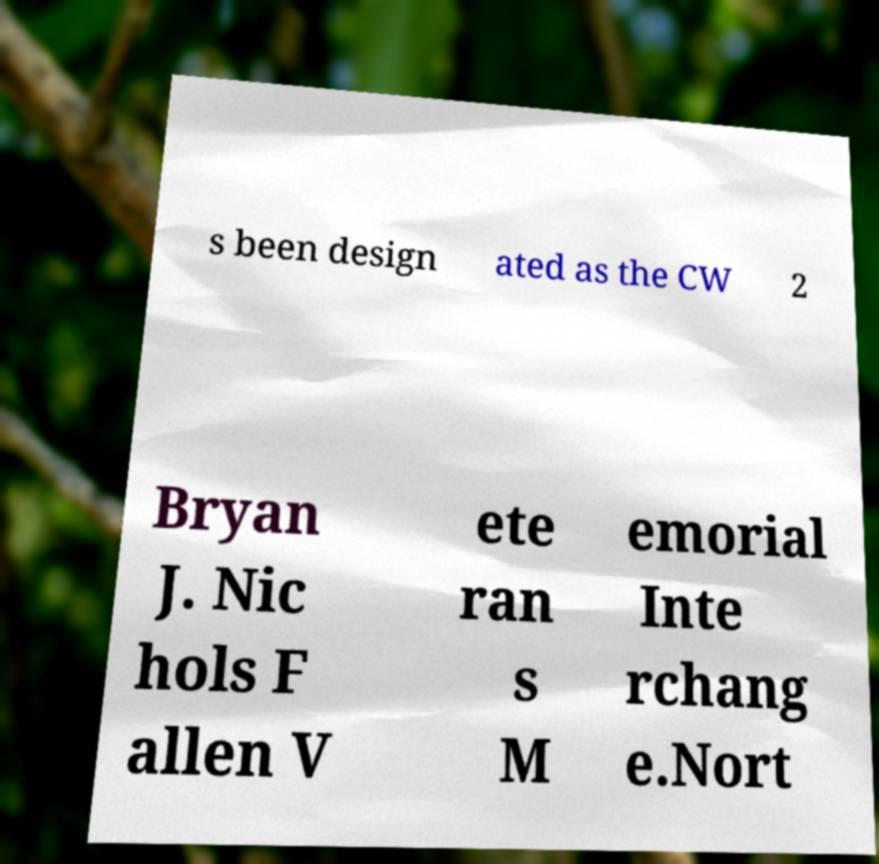For documentation purposes, I need the text within this image transcribed. Could you provide that? s been design ated as the CW 2 Bryan J. Nic hols F allen V ete ran s M emorial Inte rchang e.Nort 